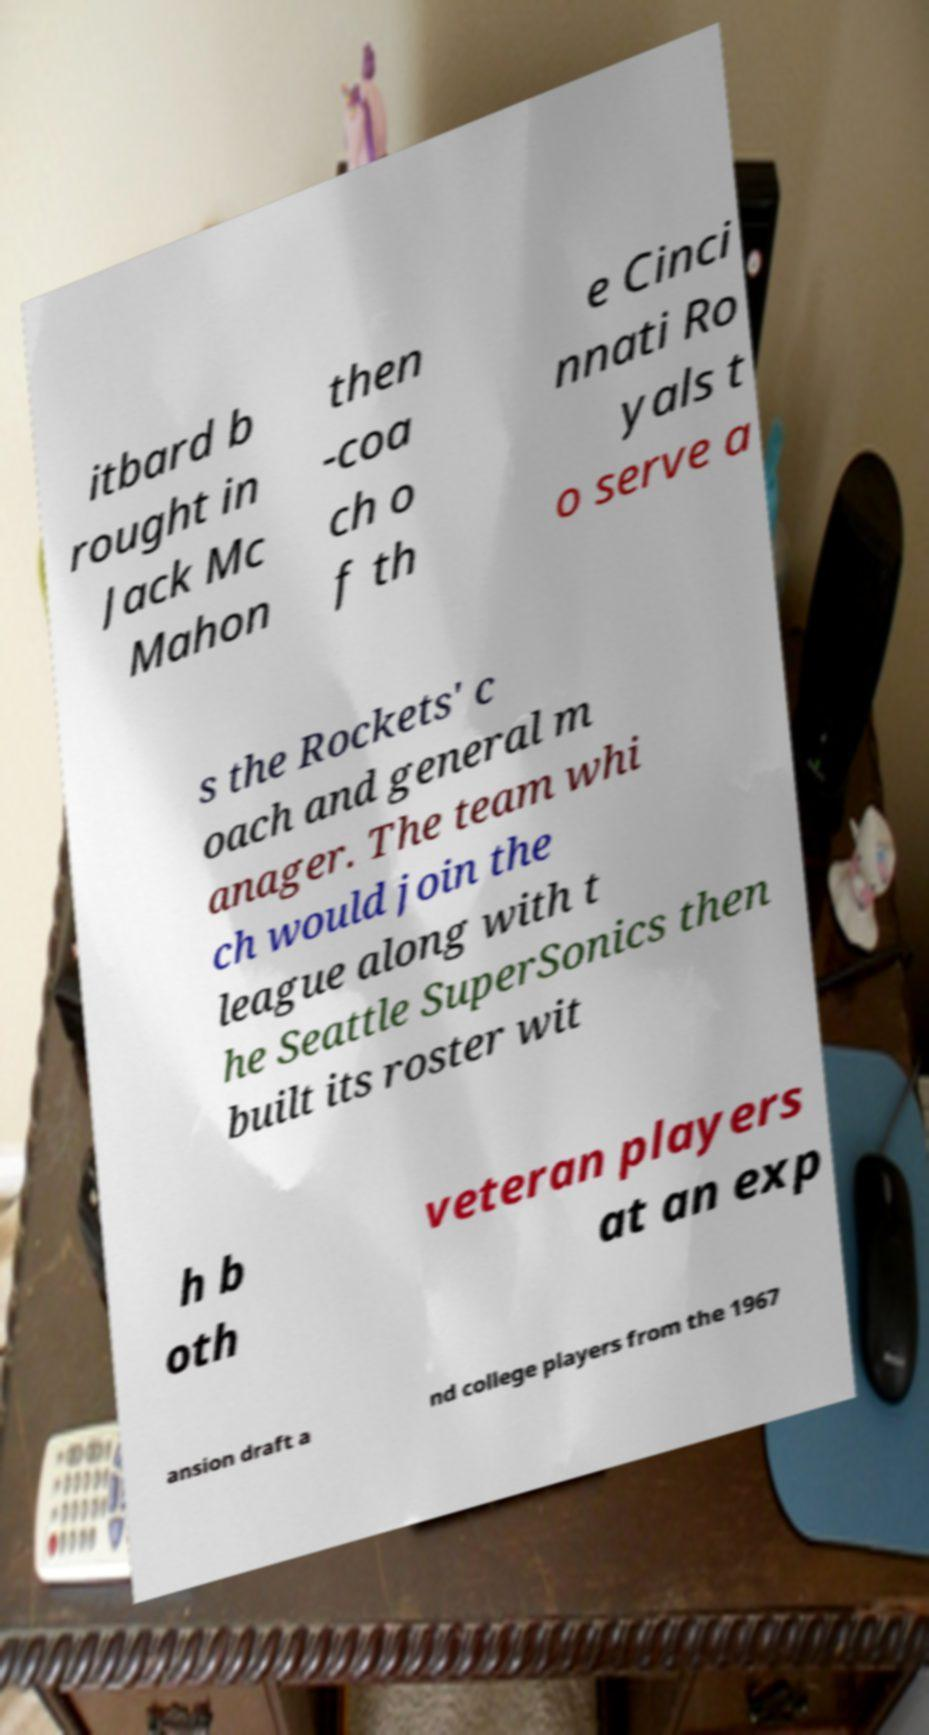What messages or text are displayed in this image? I need them in a readable, typed format. itbard b rought in Jack Mc Mahon then -coa ch o f th e Cinci nnati Ro yals t o serve a s the Rockets' c oach and general m anager. The team whi ch would join the league along with t he Seattle SuperSonics then built its roster wit h b oth veteran players at an exp ansion draft a nd college players from the 1967 